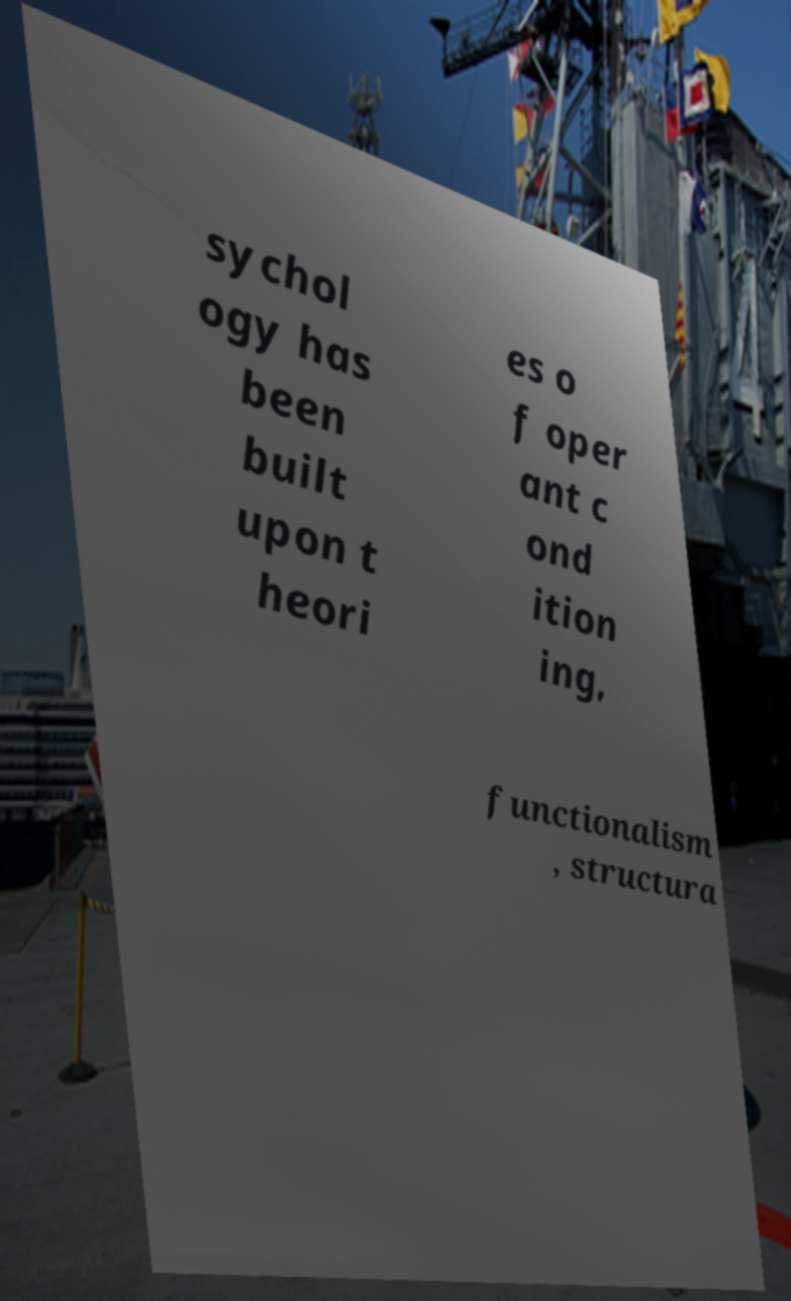Please identify and transcribe the text found in this image. sychol ogy has been built upon t heori es o f oper ant c ond ition ing, functionalism , structura 